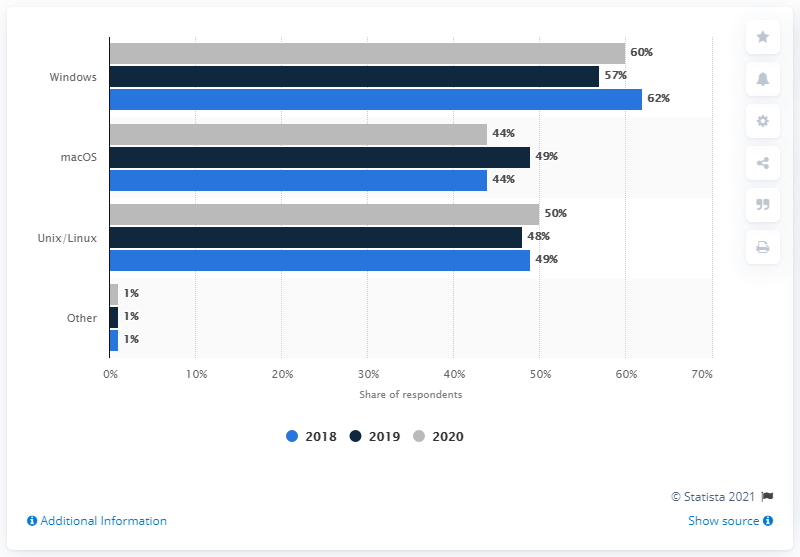List a handful of essential elements in this visual. In 2020, the majority of software developers reported using Windows as their preferred development environment. 